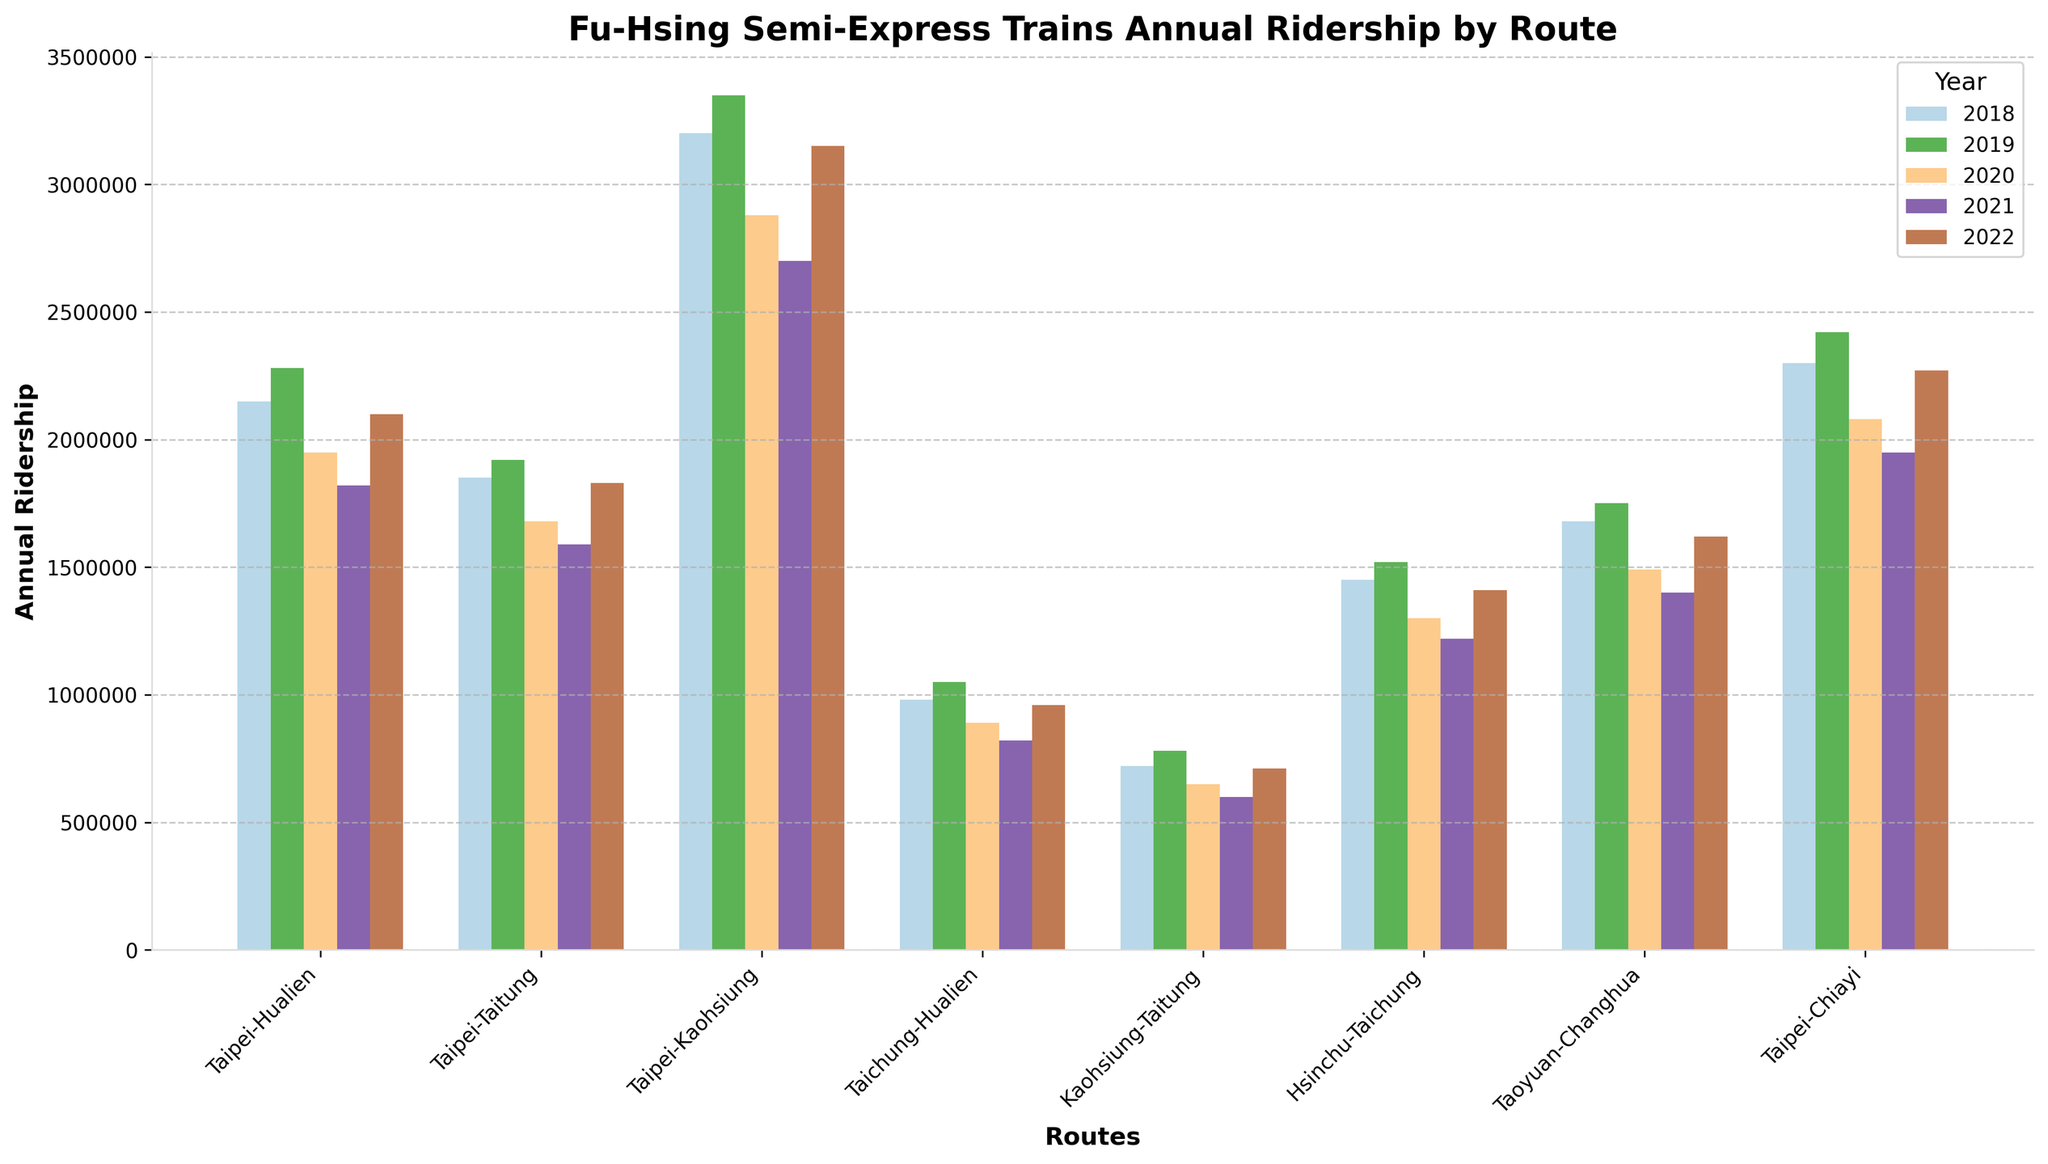Which route saw the highest ridership in 2022? Look at the height of the bars corresponding to 2022 for all routes. The tallest bar in 2022 represents the route with the highest ridership.
Answer: Taipei-Kaohsiung Which route experienced the most significant decrease in ridership from 2019 to 2020? Compare the heights of the bars for 2019 and 2020 for each route. Calculate the difference for each route and identify the largest decrease.
Answer: Taipei-Kaohsiung Which route had the lowest ridership in 2021? Identify the shortest bar for 2021 among all the routes.
Answer: Kaohsiung-Taitung How did the Taipei-Chiayi route's ridership change from 2018 to 2022? Compare the heights of the bars for Taipei-Chiayi from 2018 to 2022.
Answer: It decreased and then increased What was the total ridership for the Taipei-Taitung route over all the years shown? Sum the heights of the bars for Taipei-Taitung across all years (2018-2022). The values are 1850000 + 1920000 + 1680000 + 1590000 + 1830000.
Answer: 8870000 Which two routes had nearly equal ridership in 2020? Compare the heights of the bars for 2020 and identify pairs of bars with almost the same height.
Answer: Taichung-Hualien and Kaohsiung-Taitung Which year saw the highest overall ridership for the route from Taichung to Hualien? Identify the tallest bar for Taichung-Hualien across all years.
Answer: 2019 What trend can be observed for the ridership of the Taipei-Hualien route from 2018 to 2021? Observe the direction (increasing or decreasing) of the bar heights from 2018 to 2021 for Taipei-Hualien.
Answer: Decreasing trend Comparing 2018 and 2022, which route had a more significant increase in ridership: Taipei-Hualien or Taipei-Taitung? Calculate the difference in bar heights between 2018 and 2022 for both routes and compare. Taipei-Hualien: 2100000 - 2150000; Taipei-Taitung: 1830000 - 1850000.
Answer: Taipei-Hualien What is the average annual ridership of the Hsinchu-Taichung route across all the years shown? Calculate the total ridership for Hsinchu-Taichung across the years and then divide by the number of years. (1450000 + 1520000 + 1300000 + 1220000 + 1410000) / 5
Answer: 1380000 